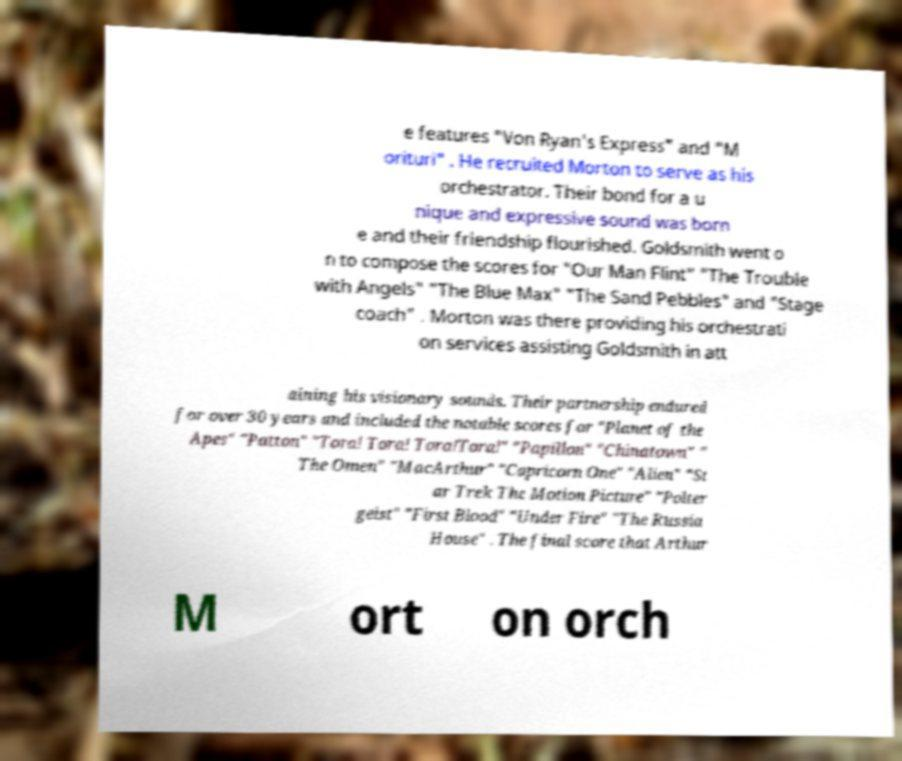I need the written content from this picture converted into text. Can you do that? e features "Von Ryan's Express" and "M orituri" . He recruited Morton to serve as his orchestrator. Their bond for a u nique and expressive sound was born e and their friendship flourished. Goldsmith went o n to compose the scores for "Our Man Flint" "The Trouble with Angels" "The Blue Max" "The Sand Pebbles" and "Stage coach" . Morton was there providing his orchestrati on services assisting Goldsmith in att aining his visionary sounds. Their partnership endured for over 30 years and included the notable scores for "Planet of the Apes" "Patton" "Tora! Tora! Tora!Tora!" "Papillon" "Chinatown" " The Omen" "MacArthur" "Capricorn One" "Alien" "St ar Trek The Motion Picture" "Polter geist" "First Blood" "Under Fire" "The Russia House" . The final score that Arthur M ort on orch 